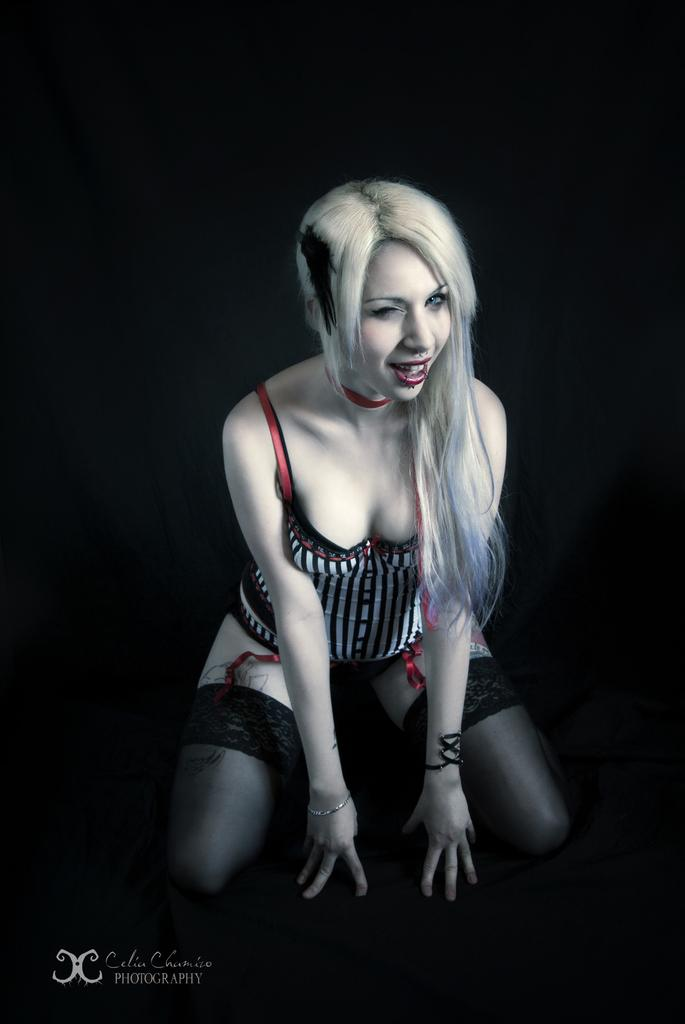Who is the main subject in the image? There is a woman in the image. What position is the woman in? The woman is in a squat position. What can be seen behind the woman in the image? There is a dark background in the image. Is there any additional information or branding on the image? Yes, there is a watermark on the image. How many babies are being held by the woman in the image? There are no babies present in the image; it features a woman in a squat position with a dark background and a watermark. What type of hammer is being used by the woman in the image? There is no hammer present in the image; it features a woman in a squat position with a dark background and a watermark. 